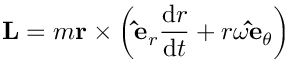<formula> <loc_0><loc_0><loc_500><loc_500>L = m r \times \left ( \hat { e } _ { r } { \frac { d r } { d t } } + r \omega \hat { e } _ { \theta } \right )</formula> 